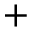<formula> <loc_0><loc_0><loc_500><loc_500>+</formula> 